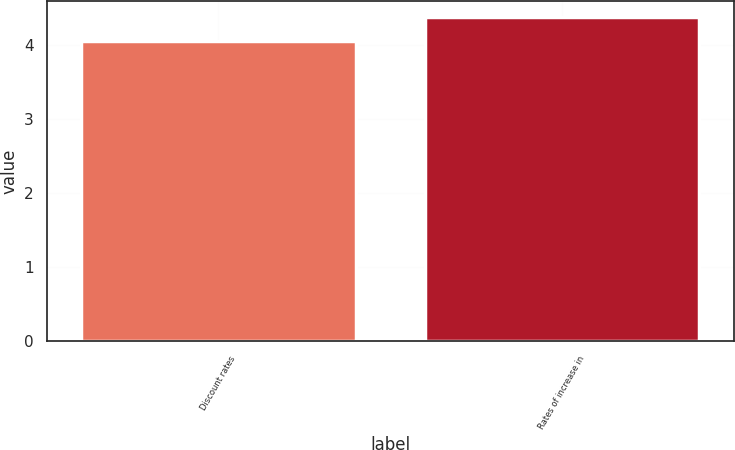<chart> <loc_0><loc_0><loc_500><loc_500><bar_chart><fcel>Discount rates<fcel>Rates of increase in<nl><fcel>4.06<fcel>4.38<nl></chart> 